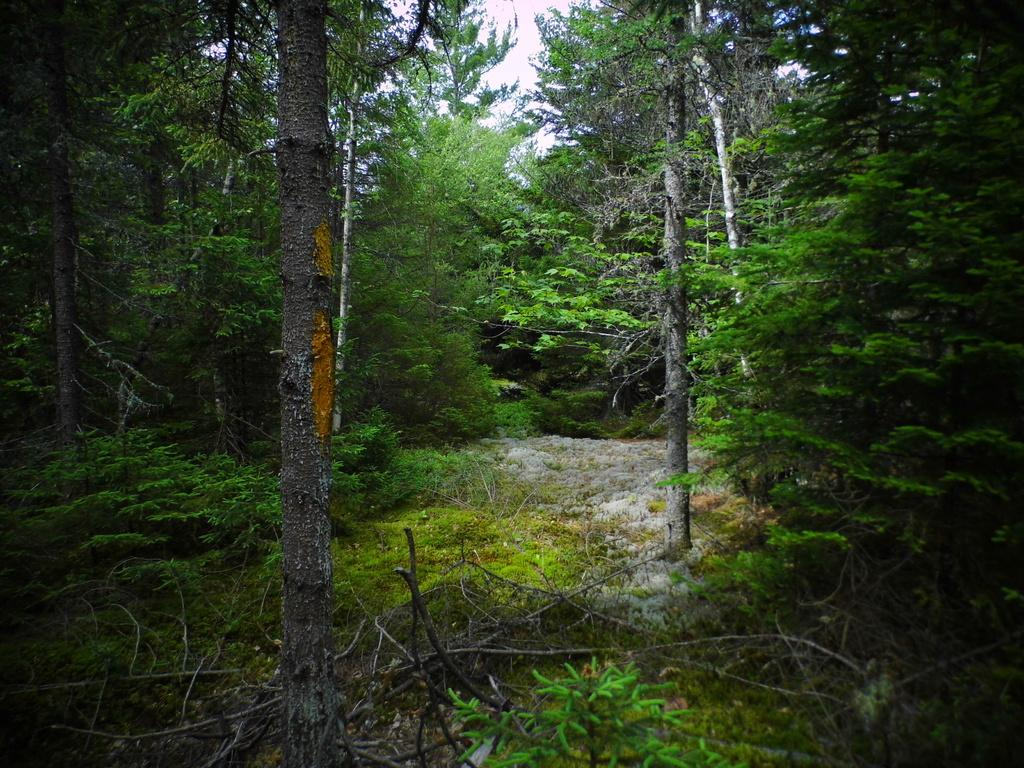What type of vegetation can be seen in the image? There are trees, plants, and grass visible in the image. What is the ground covered with in the image? The ground is covered with grass in the image. What can be seen in the center of the image? There is a path in the center of the image. What is visible at the top of the image? The sky is visible at the top of the image. What additional details can be observed on the ground in the image? Dried stems are present on the ground in the image. What type of crib can be seen in the image? There is no crib present in the image. What team is responsible for maintaining the path in the image? The image does not provide information about a team responsible for maintaining the path. 